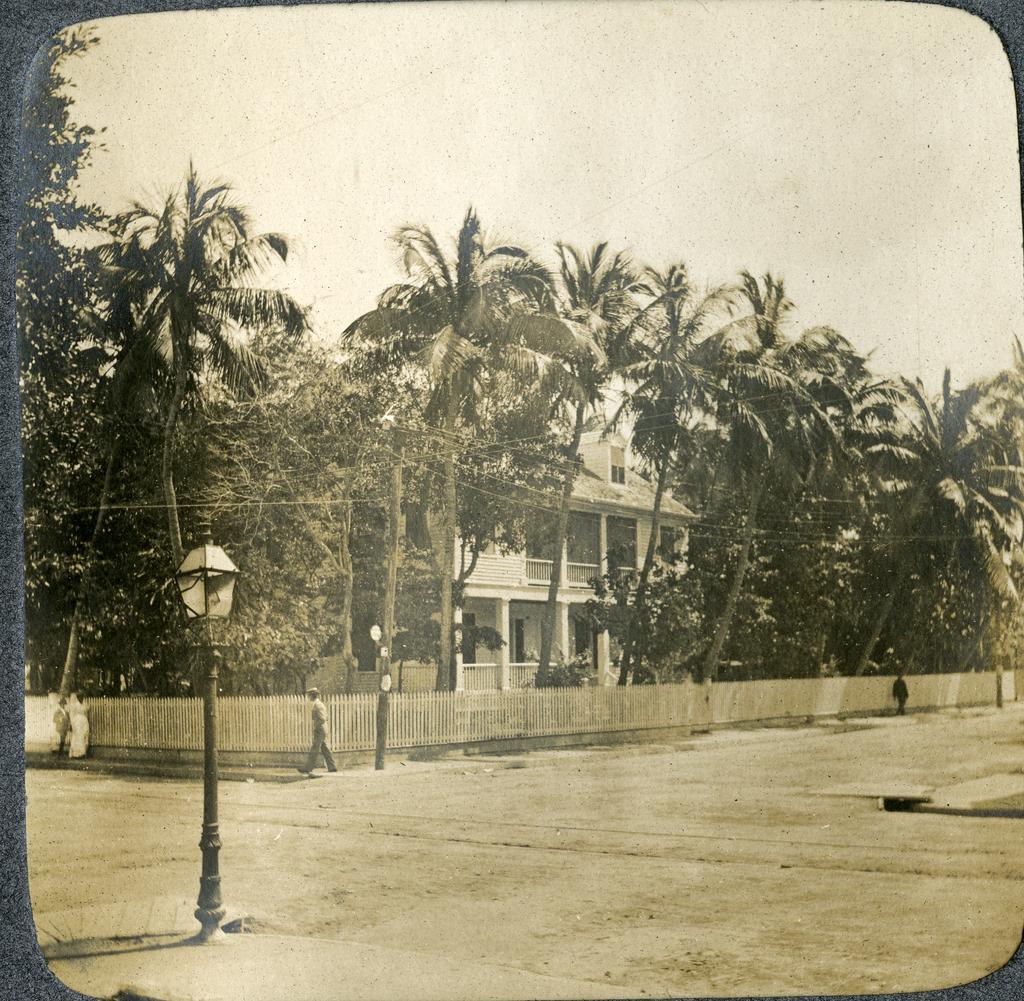How would you summarize this image in a sentence or two? Here this is an edited image, in which we can see people standing and walking on the road and we can also see a house present and that is covered with a wooden railing outside and we can also see lamp posts present and we can also see plants and trees present and we can see the sky is cloudy. 